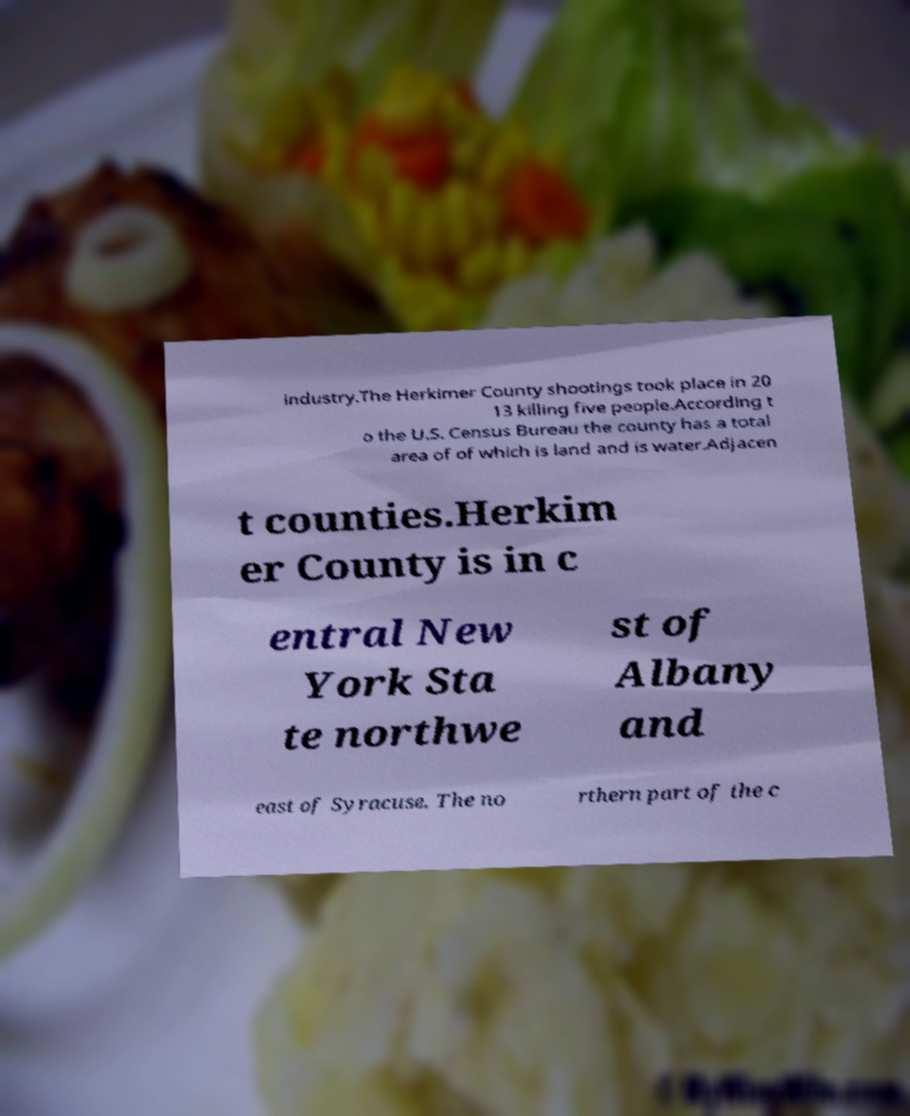Can you accurately transcribe the text from the provided image for me? industry.The Herkimer County shootings took place in 20 13 killing five people.According t o the U.S. Census Bureau the county has a total area of of which is land and is water.Adjacen t counties.Herkim er County is in c entral New York Sta te northwe st of Albany and east of Syracuse. The no rthern part of the c 